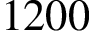Convert formula to latex. <formula><loc_0><loc_0><loc_500><loc_500>1 2 0 0</formula> 